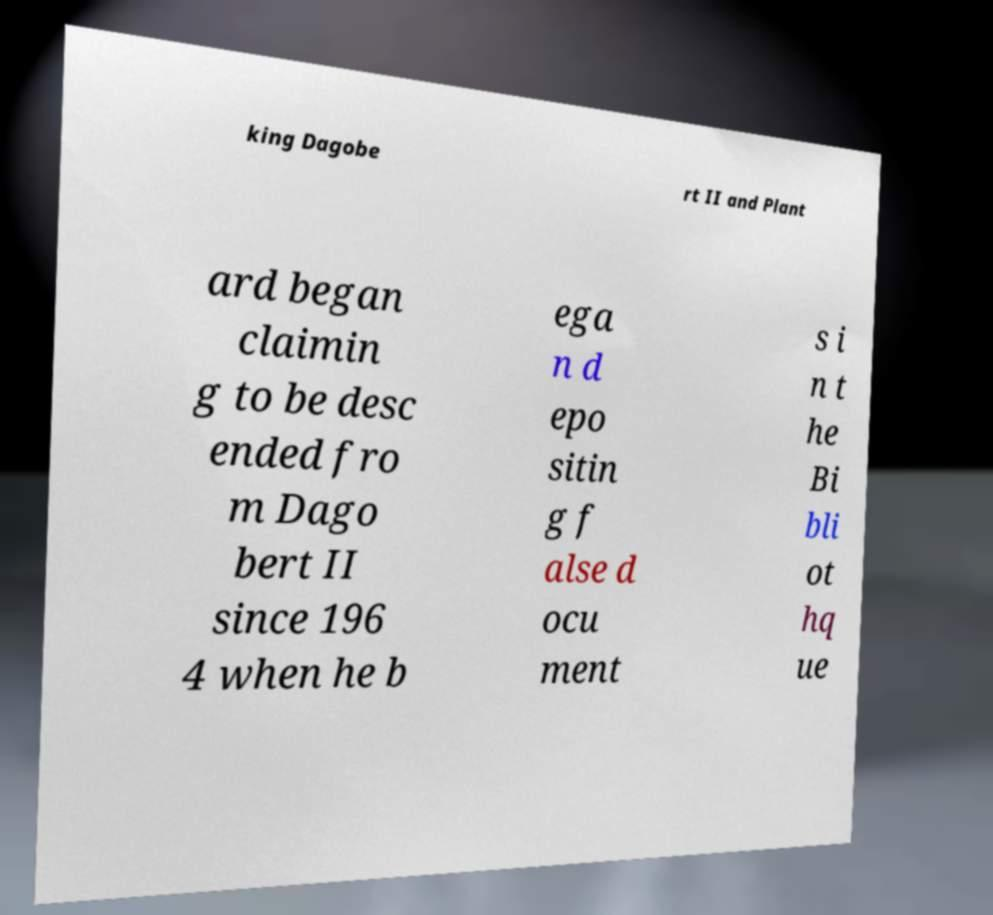What messages or text are displayed in this image? I need them in a readable, typed format. king Dagobe rt II and Plant ard began claimin g to be desc ended fro m Dago bert II since 196 4 when he b ega n d epo sitin g f alse d ocu ment s i n t he Bi bli ot hq ue 